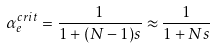Convert formula to latex. <formula><loc_0><loc_0><loc_500><loc_500>\alpha _ { e } ^ { c r i t } = \frac { 1 } { 1 + ( N - 1 ) s } \approx \frac { 1 } { 1 + N s }</formula> 